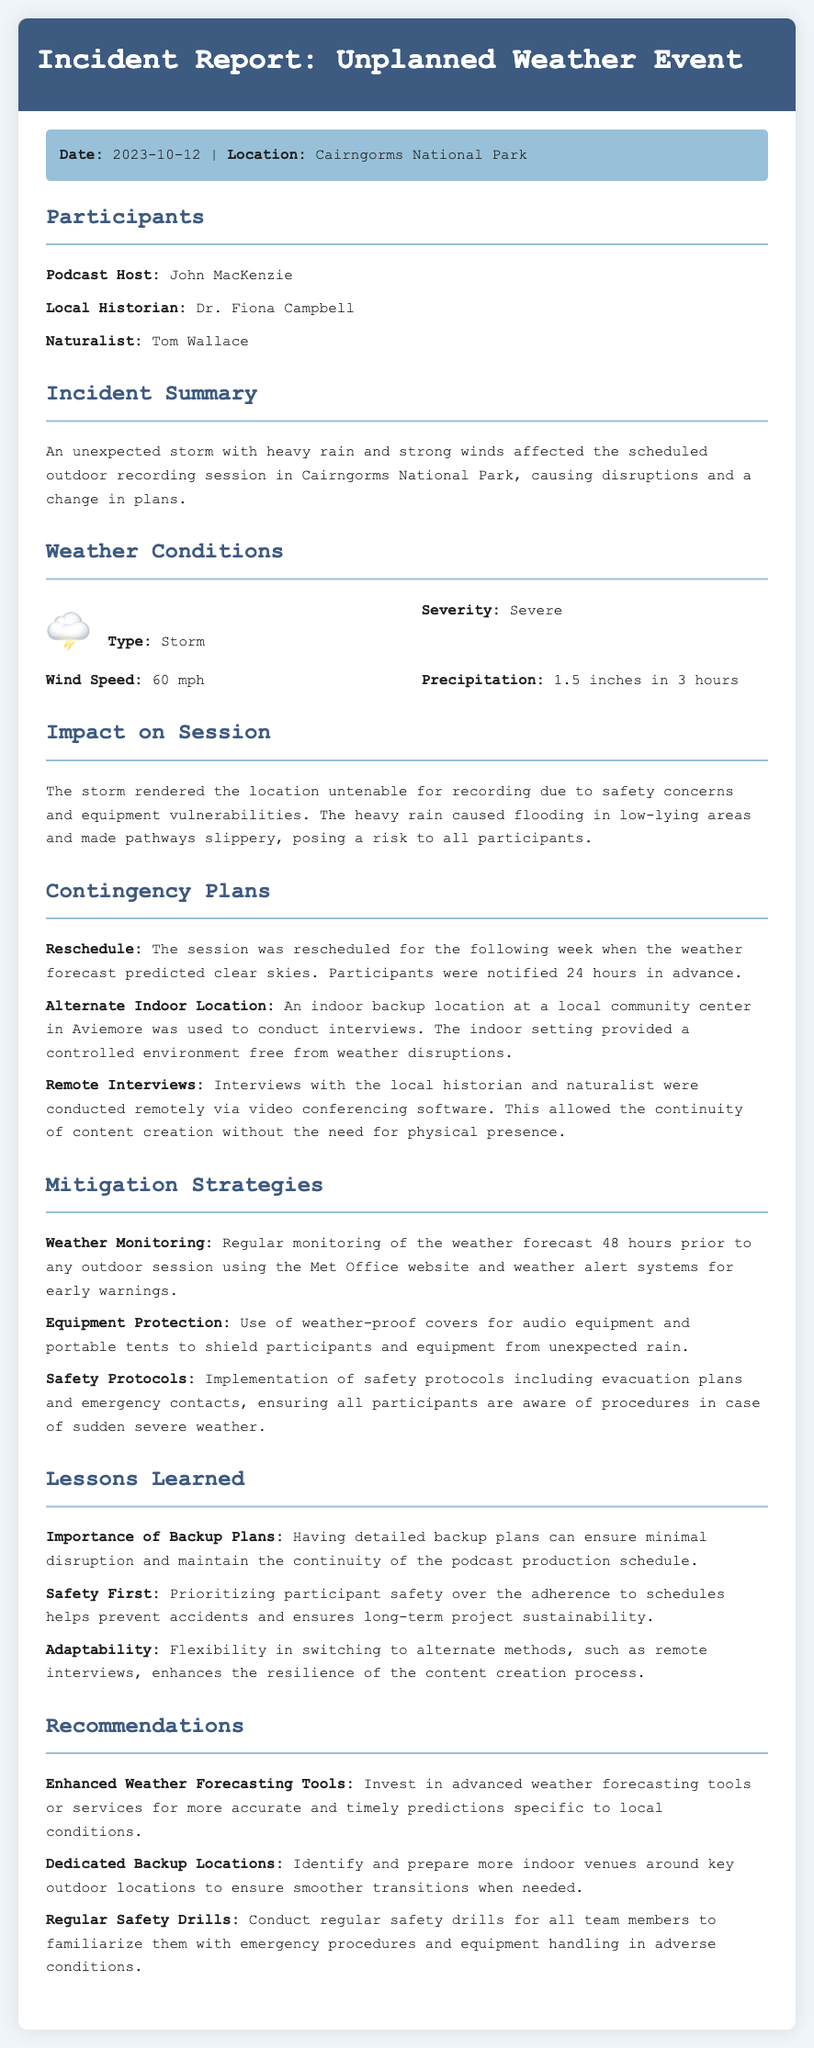What was the date of the incident report? The date is mentioned in the meta-info section of the document.
Answer: 2023-10-12 Where did the weather event occur? The location is specified in the meta-info section.
Answer: Cairngorms National Park What type of weather event occurred? The type of the weather event is listed in the weather conditions section.
Answer: Storm What was the wind speed during the storm? The wind speed is a specific detail provided under weather conditions.
Answer: 60 mph What contingency plan involved an indoor location? The document lists specific contingency plans in a section.
Answer: Alternate Indoor Location What is one of the mitigation strategies mentioned? The strategies are outlined in the mitigation strategies section.
Answer: Weather Monitoring Which participant is a local historian? The participants section clearly specifies the role of each individual.
Answer: Dr. Fiona Campbell What lesson learned emphasizes safety? The lessons learned section discusses key takeaways, including safety emphasis.
Answer: Safety First How much precipitation was recorded during the storm? The amount of precipitation is noted in the weather conditions section.
Answer: 1.5 inches in 3 hours 